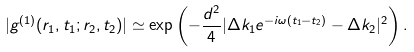<formula> <loc_0><loc_0><loc_500><loc_500>| g ^ { ( 1 ) } ( { r } _ { 1 } , t _ { 1 } ; { r } _ { 2 } , t _ { 2 } ) | \simeq \exp \left ( - \frac { d ^ { 2 } } { 4 } | \Delta { k } _ { 1 } e ^ { - i \omega ( t _ { 1 } - t _ { 2 } ) } - \Delta { k } _ { 2 } | ^ { 2 } \right ) .</formula> 